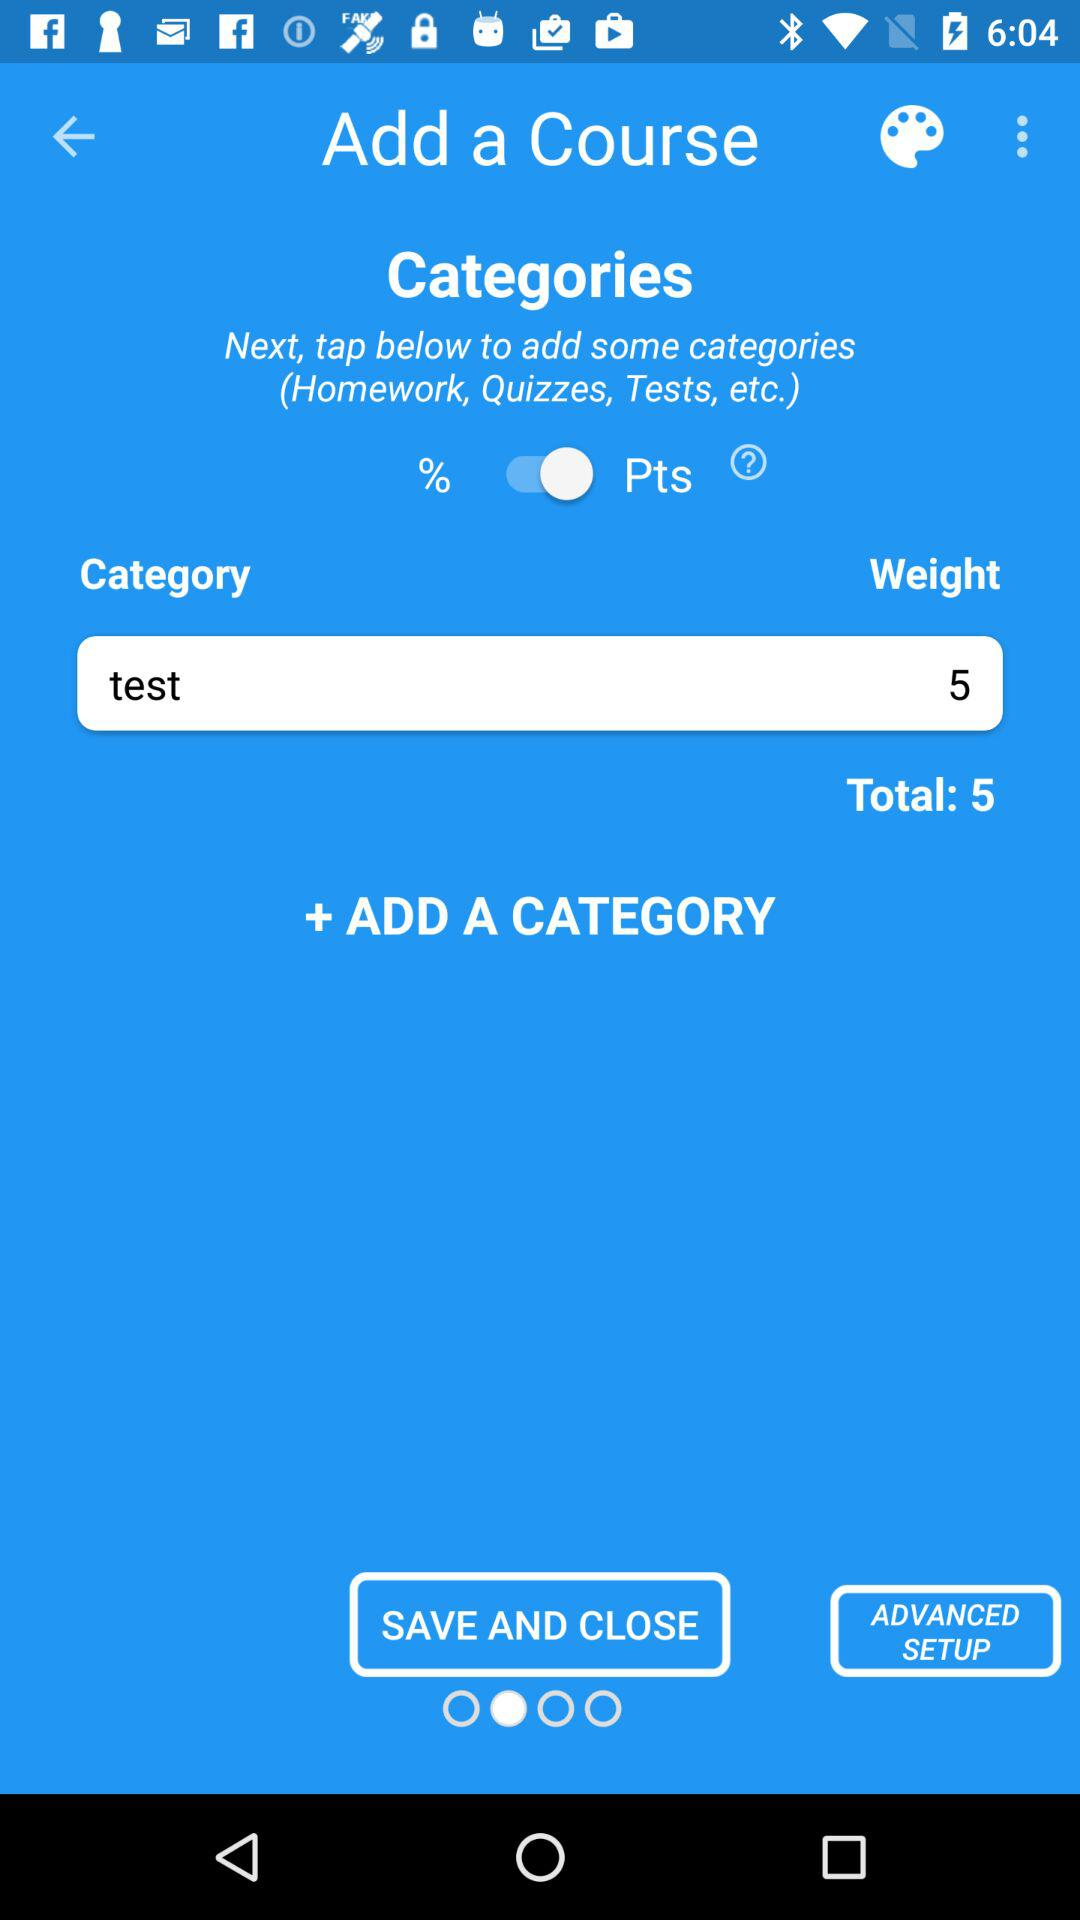How many categories are there?
Answer the question using a single word or phrase. 1 